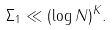<formula> <loc_0><loc_0><loc_500><loc_500>\Sigma _ { 1 } \ll ( \log N ) ^ { K } .</formula> 